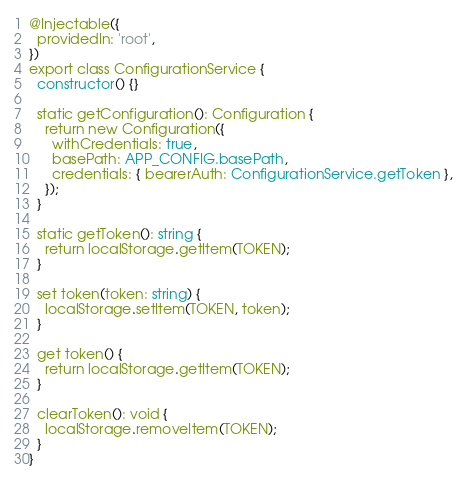<code> <loc_0><loc_0><loc_500><loc_500><_TypeScript_>
@Injectable({
  providedIn: 'root',
})
export class ConfigurationService {
  constructor() {}

  static getConfiguration(): Configuration {
    return new Configuration({
      withCredentials: true,
      basePath: APP_CONFIG.basePath,
      credentials: { bearerAuth: ConfigurationService.getToken },
    });
  }

  static getToken(): string {
    return localStorage.getItem(TOKEN);
  }

  set token(token: string) {
    localStorage.setItem(TOKEN, token);
  }

  get token() {
    return localStorage.getItem(TOKEN);
  }

  clearToken(): void {
    localStorage.removeItem(TOKEN);
  }
}
</code> 